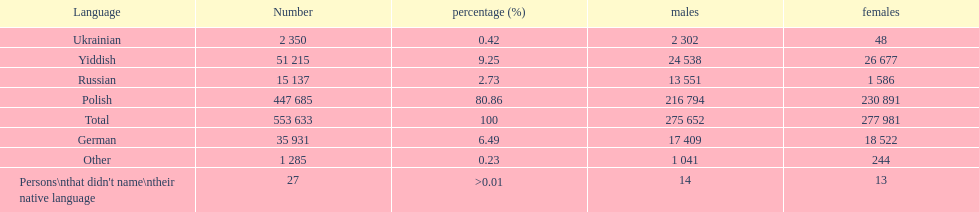Which language did the most people in the imperial census of 1897 speak in the p&#322;ock governorate? Polish. 